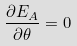<formula> <loc_0><loc_0><loc_500><loc_500>\frac { \partial E _ { A } } { \partial \theta } = 0</formula> 